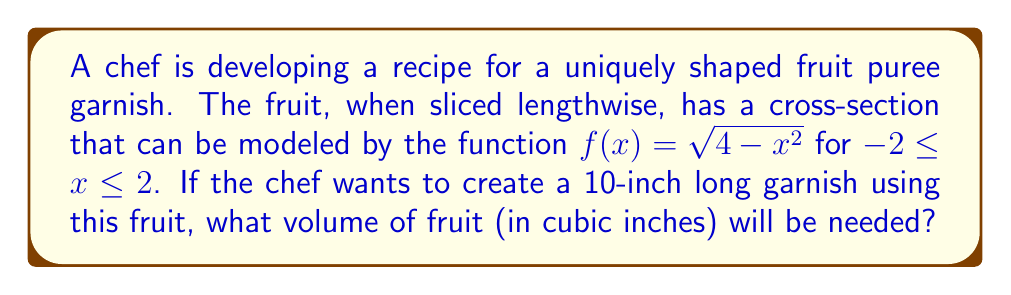Show me your answer to this math problem. To solve this problem, we'll use the method of integration to calculate the volume of a solid of revolution.

Step 1: Identify the function and the axis of rotation.
The function is $f(x) = \sqrt{4-x^2}$, and we're rotating it around the x-axis.

Step 2: Set up the integral for the volume of a solid of revolution.
The volume formula is:
$$V = \pi \int_{a}^{b} [f(x)]^2 dx$$
Where $a = -2$ and $b = 2$ (the bounds of x).

Step 3: Substitute the function into the integral.
$$V = \pi \int_{-2}^{2} (\sqrt{4-x^2})^2 dx = \pi \int_{-2}^{2} (4-x^2) dx$$

Step 4: Evaluate the integral.
$$V = \pi \left[4x - \frac{x^3}{3}\right]_{-2}^{2}$$

Step 5: Calculate the result.
$$V = \pi \left[\left(4(2) - \frac{2^3}{3}\right) - \left(4(-2) - \frac{(-2)^3}{3}\right)\right]$$
$$V = \pi \left[\left(8 - \frac{8}{3}\right) - \left(-8 - \frac{-8}{3}\right)\right]$$
$$V = \pi \left[\frac{16}{3} + \frac{16}{3}\right] = \pi \cdot \frac{32}{3} = \frac{32\pi}{3}$$

Step 6: Adjust for the length.
The volume we calculated is for a 4-inch long section (from -2 to 2). For a 10-inch long garnish, we need to scale this volume:
$$V_{10} = \frac{10}{4} \cdot \frac{32\pi}{3} = \frac{80\pi}{3} \approx 83.78$$

Therefore, the chef will need approximately 83.78 cubic inches of fruit for the 10-inch long garnish.
Answer: $\frac{80\pi}{3}$ cubic inches 